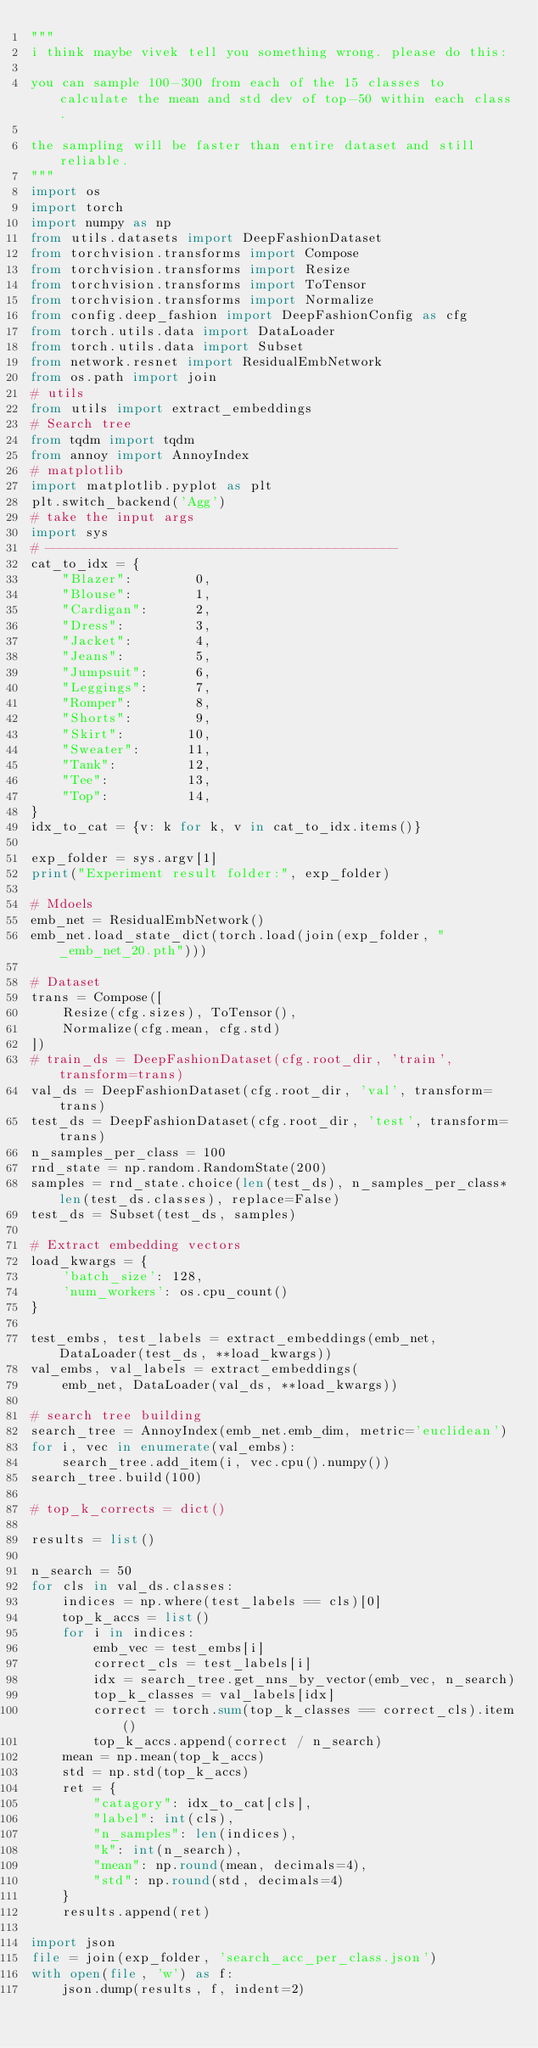Convert code to text. <code><loc_0><loc_0><loc_500><loc_500><_Python_>"""
i think maybe vivek tell you something wrong. please do this:

you can sample 100-300 from each of the 15 classes to calculate the mean and std dev of top-50 within each class.

the sampling will be faster than entire dataset and still reliable.
"""
import os
import torch
import numpy as np
from utils.datasets import DeepFashionDataset
from torchvision.transforms import Compose
from torchvision.transforms import Resize
from torchvision.transforms import ToTensor
from torchvision.transforms import Normalize
from config.deep_fashion import DeepFashionConfig as cfg
from torch.utils.data import DataLoader
from torch.utils.data import Subset
from network.resnet import ResidualEmbNetwork
from os.path import join
# utils
from utils import extract_embeddings
# Search tree
from tqdm import tqdm
from annoy import AnnoyIndex
# matplotlib
import matplotlib.pyplot as plt
plt.switch_backend('Agg')
# take the input args
import sys
# ---------------------------------------------
cat_to_idx = {
    "Blazer":        0,
    "Blouse":        1,
    "Cardigan":      2,
    "Dress":         3,
    "Jacket":        4,
    "Jeans":         5,
    "Jumpsuit":      6,
    "Leggings":      7,
    "Romper":        8,
    "Shorts":        9,
    "Skirt":        10,
    "Sweater":      11,
    "Tank":         12,
    "Tee":          13,
    "Top":          14,
}
idx_to_cat = {v: k for k, v in cat_to_idx.items()}

exp_folder = sys.argv[1]
print("Experiment result folder:", exp_folder)

# Mdoels
emb_net = ResidualEmbNetwork()
emb_net.load_state_dict(torch.load(join(exp_folder, "_emb_net_20.pth")))

# Dataset
trans = Compose([
    Resize(cfg.sizes), ToTensor(),
    Normalize(cfg.mean, cfg.std)
])
# train_ds = DeepFashionDataset(cfg.root_dir, 'train', transform=trans)
val_ds = DeepFashionDataset(cfg.root_dir, 'val', transform=trans)
test_ds = DeepFashionDataset(cfg.root_dir, 'test', transform=trans)
n_samples_per_class = 100
rnd_state = np.random.RandomState(200)
samples = rnd_state.choice(len(test_ds), n_samples_per_class*len(test_ds.classes), replace=False)
test_ds = Subset(test_ds, samples)

# Extract embedding vectors
load_kwargs = {
    'batch_size': 128,
    'num_workers': os.cpu_count()
}

test_embs, test_labels = extract_embeddings(emb_net, DataLoader(test_ds, **load_kwargs))
val_embs, val_labels = extract_embeddings(
    emb_net, DataLoader(val_ds, **load_kwargs))

# search tree building
search_tree = AnnoyIndex(emb_net.emb_dim, metric='euclidean')
for i, vec in enumerate(val_embs):
    search_tree.add_item(i, vec.cpu().numpy())
search_tree.build(100)

# top_k_corrects = dict()

results = list()

n_search = 50
for cls in val_ds.classes:
    indices = np.where(test_labels == cls)[0]
    top_k_accs = list()
    for i in indices:
        emb_vec = test_embs[i]
        correct_cls = test_labels[i]
        idx = search_tree.get_nns_by_vector(emb_vec, n_search)
        top_k_classes = val_labels[idx]
        correct = torch.sum(top_k_classes == correct_cls).item()
        top_k_accs.append(correct / n_search)
    mean = np.mean(top_k_accs)
    std = np.std(top_k_accs)
    ret = {
        "catagory": idx_to_cat[cls],
        "label": int(cls),
        "n_samples": len(indices),
        "k": int(n_search),
        "mean": np.round(mean, decimals=4),
        "std": np.round(std, decimals=4)
    }
    results.append(ret)

import json
file = join(exp_folder, 'search_acc_per_class.json')
with open(file, 'w') as f:
    json.dump(results, f, indent=2)
 </code> 